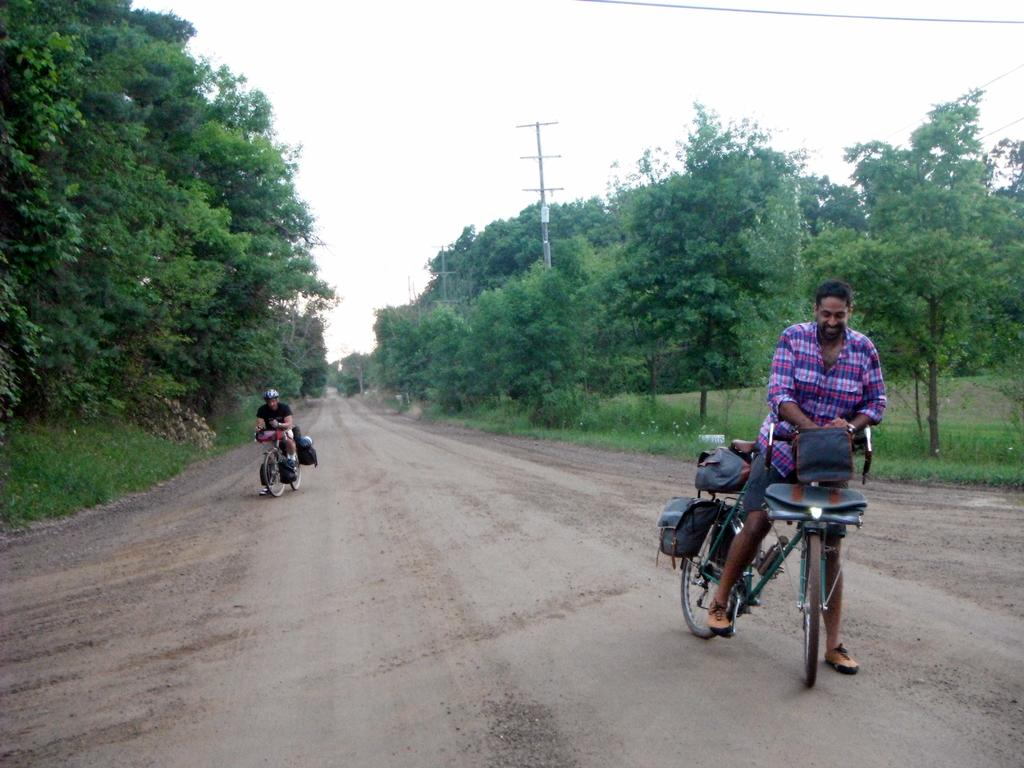What can be seen in the background of the image? There is a sky and trees in the image. What is located near the trees in the image? There is a current pole in the image. How many people are in the image? There are two people in the image. What are the people doing in the image? The people are sitting on bicycles. What are the bicycles carrying in the image? There are bags on the bicycles. What type of furniture can be seen in the image? There is no furniture present in the image. Can you describe the pear that is being held by one of the people in the image? There is no pear present in the image; the people are sitting on bicycles with bags. 